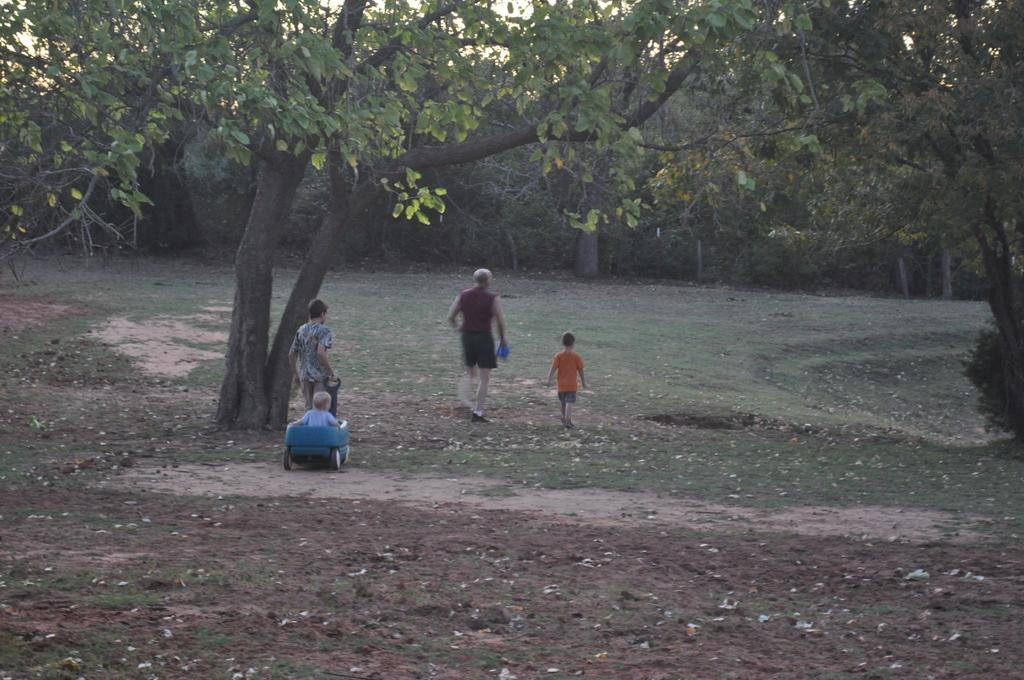What are the main subjects in the image? There are small kids playing in the image. Where are the kids playing? The kids are playing in a playground. What can be seen in the middle of the image? There is a huge tree in the middle of the image. What is visible in the background of the image? There are many trees in the background of the image. What type of berry is hanging from the tree in the image? There is no berry hanging from the tree in the image; it is a huge tree without any visible fruits or berries. 